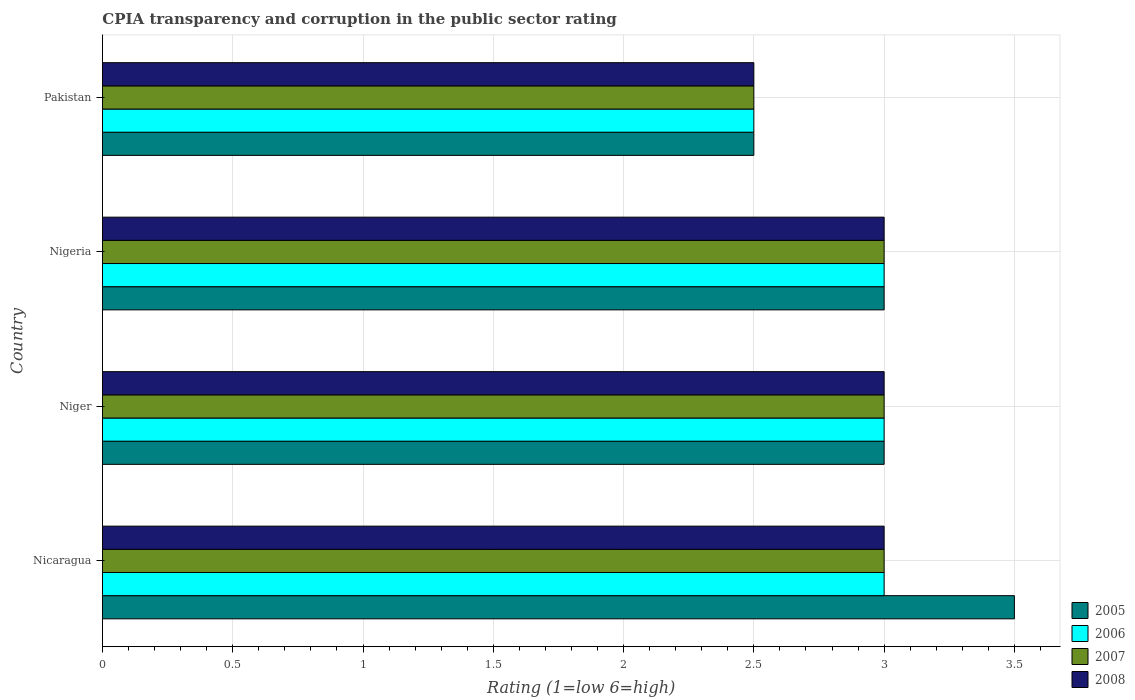How many different coloured bars are there?
Your answer should be compact. 4. How many bars are there on the 2nd tick from the bottom?
Offer a very short reply. 4. Across all countries, what is the minimum CPIA rating in 2007?
Ensure brevity in your answer.  2.5. In which country was the CPIA rating in 2005 maximum?
Your response must be concise. Nicaragua. In which country was the CPIA rating in 2005 minimum?
Ensure brevity in your answer.  Pakistan. What is the difference between the CPIA rating in 2006 in Nicaragua and that in Niger?
Your answer should be compact. 0. What is the average CPIA rating in 2007 per country?
Ensure brevity in your answer.  2.88. In how many countries, is the CPIA rating in 2008 greater than 2.6 ?
Offer a very short reply. 3. Is the CPIA rating in 2008 in Nigeria less than that in Pakistan?
Offer a very short reply. No. In how many countries, is the CPIA rating in 2008 greater than the average CPIA rating in 2008 taken over all countries?
Your response must be concise. 3. Is the sum of the CPIA rating in 2007 in Nicaragua and Nigeria greater than the maximum CPIA rating in 2008 across all countries?
Make the answer very short. Yes. Is it the case that in every country, the sum of the CPIA rating in 2005 and CPIA rating in 2006 is greater than the sum of CPIA rating in 2007 and CPIA rating in 2008?
Provide a short and direct response. No. What does the 3rd bar from the top in Pakistan represents?
Provide a succinct answer. 2006. What does the 2nd bar from the bottom in Nigeria represents?
Your answer should be compact. 2006. Is it the case that in every country, the sum of the CPIA rating in 2006 and CPIA rating in 2008 is greater than the CPIA rating in 2007?
Your answer should be compact. Yes. Are all the bars in the graph horizontal?
Keep it short and to the point. Yes. What is the difference between two consecutive major ticks on the X-axis?
Provide a succinct answer. 0.5. Are the values on the major ticks of X-axis written in scientific E-notation?
Offer a terse response. No. Does the graph contain any zero values?
Keep it short and to the point. No. Where does the legend appear in the graph?
Make the answer very short. Bottom right. How many legend labels are there?
Offer a terse response. 4. What is the title of the graph?
Give a very brief answer. CPIA transparency and corruption in the public sector rating. What is the label or title of the X-axis?
Your response must be concise. Rating (1=low 6=high). What is the Rating (1=low 6=high) of 2005 in Nicaragua?
Your answer should be very brief. 3.5. What is the Rating (1=low 6=high) of 2007 in Nicaragua?
Provide a succinct answer. 3. What is the Rating (1=low 6=high) in 2006 in Niger?
Your answer should be compact. 3. What is the Rating (1=low 6=high) of 2007 in Niger?
Make the answer very short. 3. What is the Rating (1=low 6=high) of 2008 in Niger?
Provide a succinct answer. 3. What is the Rating (1=low 6=high) of 2006 in Nigeria?
Your response must be concise. 3. What is the Rating (1=low 6=high) of 2005 in Pakistan?
Make the answer very short. 2.5. Across all countries, what is the maximum Rating (1=low 6=high) of 2005?
Give a very brief answer. 3.5. Across all countries, what is the maximum Rating (1=low 6=high) in 2006?
Offer a very short reply. 3. Across all countries, what is the maximum Rating (1=low 6=high) of 2008?
Ensure brevity in your answer.  3. What is the total Rating (1=low 6=high) in 2005 in the graph?
Your answer should be compact. 12. What is the total Rating (1=low 6=high) of 2006 in the graph?
Provide a short and direct response. 11.5. What is the total Rating (1=low 6=high) of 2007 in the graph?
Provide a short and direct response. 11.5. What is the difference between the Rating (1=low 6=high) in 2005 in Nicaragua and that in Niger?
Provide a short and direct response. 0.5. What is the difference between the Rating (1=low 6=high) in 2006 in Nicaragua and that in Niger?
Ensure brevity in your answer.  0. What is the difference between the Rating (1=low 6=high) of 2005 in Nicaragua and that in Nigeria?
Provide a succinct answer. 0.5. What is the difference between the Rating (1=low 6=high) in 2006 in Nicaragua and that in Nigeria?
Give a very brief answer. 0. What is the difference between the Rating (1=low 6=high) in 2007 in Nicaragua and that in Nigeria?
Provide a succinct answer. 0. What is the difference between the Rating (1=low 6=high) in 2005 in Nicaragua and that in Pakistan?
Provide a succinct answer. 1. What is the difference between the Rating (1=low 6=high) in 2007 in Nicaragua and that in Pakistan?
Offer a very short reply. 0.5. What is the difference between the Rating (1=low 6=high) in 2008 in Nicaragua and that in Pakistan?
Offer a very short reply. 0.5. What is the difference between the Rating (1=low 6=high) of 2006 in Niger and that in Nigeria?
Provide a short and direct response. 0. What is the difference between the Rating (1=low 6=high) of 2008 in Niger and that in Nigeria?
Give a very brief answer. 0. What is the difference between the Rating (1=low 6=high) in 2005 in Nigeria and that in Pakistan?
Your response must be concise. 0.5. What is the difference between the Rating (1=low 6=high) in 2006 in Nigeria and that in Pakistan?
Your response must be concise. 0.5. What is the difference between the Rating (1=low 6=high) in 2005 in Nicaragua and the Rating (1=low 6=high) in 2006 in Niger?
Offer a terse response. 0.5. What is the difference between the Rating (1=low 6=high) of 2005 in Nicaragua and the Rating (1=low 6=high) of 2007 in Pakistan?
Ensure brevity in your answer.  1. What is the difference between the Rating (1=low 6=high) in 2005 in Nicaragua and the Rating (1=low 6=high) in 2008 in Pakistan?
Your response must be concise. 1. What is the difference between the Rating (1=low 6=high) of 2006 in Nicaragua and the Rating (1=low 6=high) of 2007 in Pakistan?
Provide a succinct answer. 0.5. What is the difference between the Rating (1=low 6=high) in 2006 in Nicaragua and the Rating (1=low 6=high) in 2008 in Pakistan?
Offer a very short reply. 0.5. What is the difference between the Rating (1=low 6=high) in 2007 in Nicaragua and the Rating (1=low 6=high) in 2008 in Pakistan?
Make the answer very short. 0.5. What is the difference between the Rating (1=low 6=high) of 2005 in Niger and the Rating (1=low 6=high) of 2007 in Nigeria?
Ensure brevity in your answer.  0. What is the difference between the Rating (1=low 6=high) in 2005 in Niger and the Rating (1=low 6=high) in 2008 in Nigeria?
Offer a very short reply. 0. What is the difference between the Rating (1=low 6=high) in 2005 in Niger and the Rating (1=low 6=high) in 2006 in Pakistan?
Your answer should be very brief. 0.5. What is the difference between the Rating (1=low 6=high) of 2005 in Niger and the Rating (1=low 6=high) of 2008 in Pakistan?
Provide a succinct answer. 0.5. What is the difference between the Rating (1=low 6=high) in 2006 in Niger and the Rating (1=low 6=high) in 2007 in Pakistan?
Your answer should be very brief. 0.5. What is the difference between the Rating (1=low 6=high) of 2007 in Niger and the Rating (1=low 6=high) of 2008 in Pakistan?
Keep it short and to the point. 0.5. What is the difference between the Rating (1=low 6=high) of 2005 in Nigeria and the Rating (1=low 6=high) of 2006 in Pakistan?
Provide a succinct answer. 0.5. What is the difference between the Rating (1=low 6=high) of 2005 in Nigeria and the Rating (1=low 6=high) of 2007 in Pakistan?
Make the answer very short. 0.5. What is the average Rating (1=low 6=high) of 2005 per country?
Offer a very short reply. 3. What is the average Rating (1=low 6=high) of 2006 per country?
Ensure brevity in your answer.  2.88. What is the average Rating (1=low 6=high) of 2007 per country?
Keep it short and to the point. 2.88. What is the average Rating (1=low 6=high) in 2008 per country?
Provide a short and direct response. 2.88. What is the difference between the Rating (1=low 6=high) of 2005 and Rating (1=low 6=high) of 2006 in Nicaragua?
Provide a succinct answer. 0.5. What is the difference between the Rating (1=low 6=high) of 2005 and Rating (1=low 6=high) of 2007 in Nicaragua?
Give a very brief answer. 0.5. What is the difference between the Rating (1=low 6=high) of 2005 and Rating (1=low 6=high) of 2008 in Nicaragua?
Make the answer very short. 0.5. What is the difference between the Rating (1=low 6=high) of 2006 and Rating (1=low 6=high) of 2007 in Nicaragua?
Provide a succinct answer. 0. What is the difference between the Rating (1=low 6=high) of 2007 and Rating (1=low 6=high) of 2008 in Nicaragua?
Your answer should be compact. 0. What is the difference between the Rating (1=low 6=high) in 2005 and Rating (1=low 6=high) in 2007 in Niger?
Provide a succinct answer. 0. What is the difference between the Rating (1=low 6=high) in 2006 and Rating (1=low 6=high) in 2007 in Niger?
Keep it short and to the point. 0. What is the difference between the Rating (1=low 6=high) of 2007 and Rating (1=low 6=high) of 2008 in Niger?
Give a very brief answer. 0. What is the difference between the Rating (1=low 6=high) in 2005 and Rating (1=low 6=high) in 2006 in Nigeria?
Offer a very short reply. 0. What is the difference between the Rating (1=low 6=high) of 2006 and Rating (1=low 6=high) of 2007 in Nigeria?
Keep it short and to the point. 0. What is the difference between the Rating (1=low 6=high) in 2007 and Rating (1=low 6=high) in 2008 in Nigeria?
Your answer should be very brief. 0. What is the difference between the Rating (1=low 6=high) in 2005 and Rating (1=low 6=high) in 2007 in Pakistan?
Make the answer very short. 0. What is the difference between the Rating (1=low 6=high) of 2005 and Rating (1=low 6=high) of 2008 in Pakistan?
Your answer should be very brief. 0. What is the difference between the Rating (1=low 6=high) in 2006 and Rating (1=low 6=high) in 2007 in Pakistan?
Your answer should be very brief. 0. What is the ratio of the Rating (1=low 6=high) of 2005 in Nicaragua to that in Niger?
Give a very brief answer. 1.17. What is the ratio of the Rating (1=low 6=high) of 2007 in Nicaragua to that in Niger?
Make the answer very short. 1. What is the ratio of the Rating (1=low 6=high) in 2005 in Nicaragua to that in Nigeria?
Provide a succinct answer. 1.17. What is the ratio of the Rating (1=low 6=high) of 2007 in Nicaragua to that in Nigeria?
Offer a very short reply. 1. What is the ratio of the Rating (1=low 6=high) in 2008 in Nicaragua to that in Pakistan?
Provide a succinct answer. 1.2. What is the ratio of the Rating (1=low 6=high) in 2005 in Niger to that in Nigeria?
Keep it short and to the point. 1. What is the ratio of the Rating (1=low 6=high) of 2006 in Niger to that in Nigeria?
Keep it short and to the point. 1. What is the ratio of the Rating (1=low 6=high) in 2008 in Niger to that in Nigeria?
Your answer should be very brief. 1. What is the ratio of the Rating (1=low 6=high) in 2005 in Niger to that in Pakistan?
Give a very brief answer. 1.2. What is the ratio of the Rating (1=low 6=high) in 2008 in Niger to that in Pakistan?
Your answer should be very brief. 1.2. What is the ratio of the Rating (1=low 6=high) of 2005 in Nigeria to that in Pakistan?
Provide a short and direct response. 1.2. What is the ratio of the Rating (1=low 6=high) in 2006 in Nigeria to that in Pakistan?
Provide a succinct answer. 1.2. What is the difference between the highest and the second highest Rating (1=low 6=high) in 2005?
Provide a short and direct response. 0.5. What is the difference between the highest and the lowest Rating (1=low 6=high) of 2005?
Provide a short and direct response. 1. 